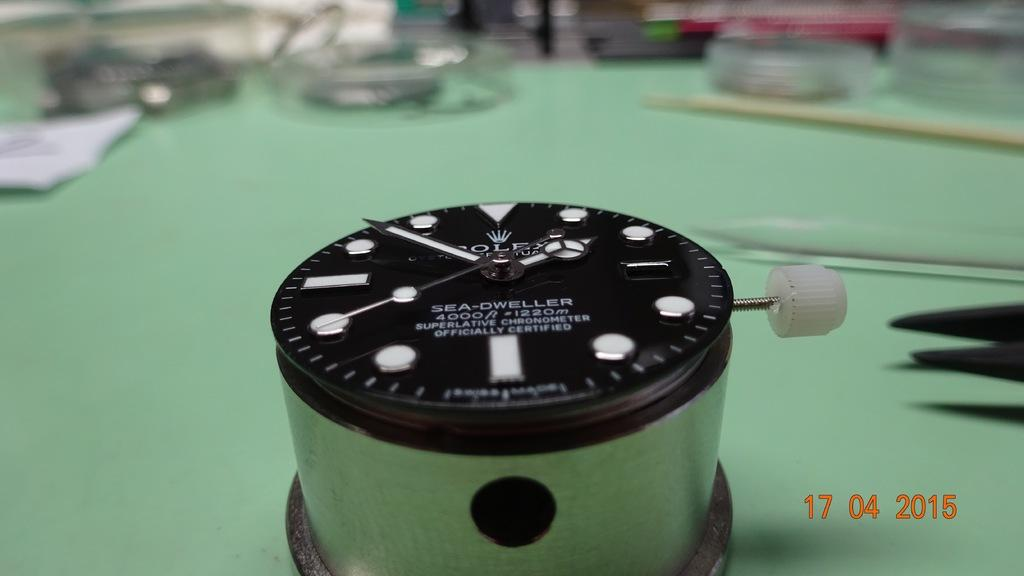<image>
Present a compact description of the photo's key features. A Sea-Dweller time piece has the time at about 1:51. 